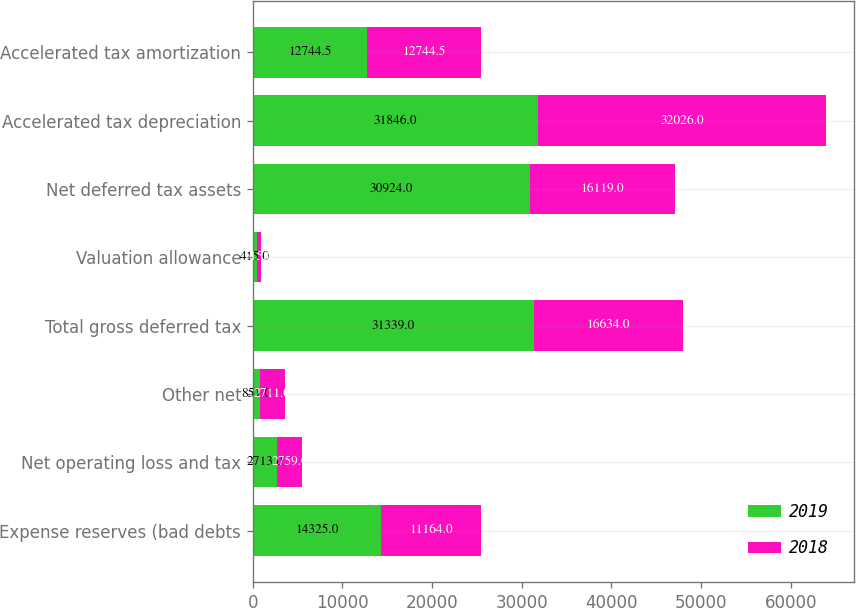Convert chart to OTSL. <chart><loc_0><loc_0><loc_500><loc_500><stacked_bar_chart><ecel><fcel>Expense reserves (bad debts<fcel>Net operating loss and tax<fcel>Other net<fcel>Total gross deferred tax<fcel>Valuation allowance<fcel>Net deferred tax assets<fcel>Accelerated tax depreciation<fcel>Accelerated tax amortization<nl><fcel>2019<fcel>14325<fcel>2713<fcel>851<fcel>31339<fcel>415<fcel>30924<fcel>31846<fcel>12744.5<nl><fcel>2018<fcel>11164<fcel>2759<fcel>2711<fcel>16634<fcel>515<fcel>16119<fcel>32026<fcel>12744.5<nl></chart> 